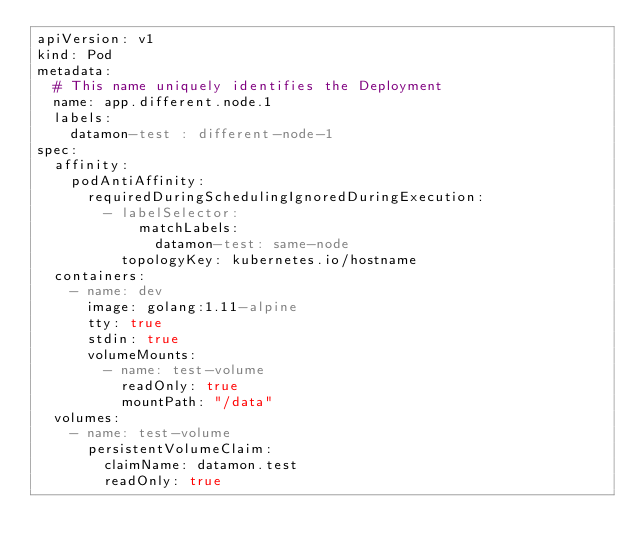Convert code to text. <code><loc_0><loc_0><loc_500><loc_500><_YAML_>apiVersion: v1
kind: Pod
metadata:
  # This name uniquely identifies the Deployment
  name: app.different.node.1
  labels:
    datamon-test : different-node-1
spec:
  affinity:
    podAntiAffinity:
      requiredDuringSchedulingIgnoredDuringExecution:
        - labelSelector:
            matchLabels:
              datamon-test: same-node
          topologyKey: kubernetes.io/hostname
  containers:
    - name: dev
      image: golang:1.11-alpine
      tty: true
      stdin: true
      volumeMounts:
        - name: test-volume
          readOnly: true
          mountPath: "/data"
  volumes:
    - name: test-volume
      persistentVolumeClaim:
        claimName: datamon.test
        readOnly: true
</code> 